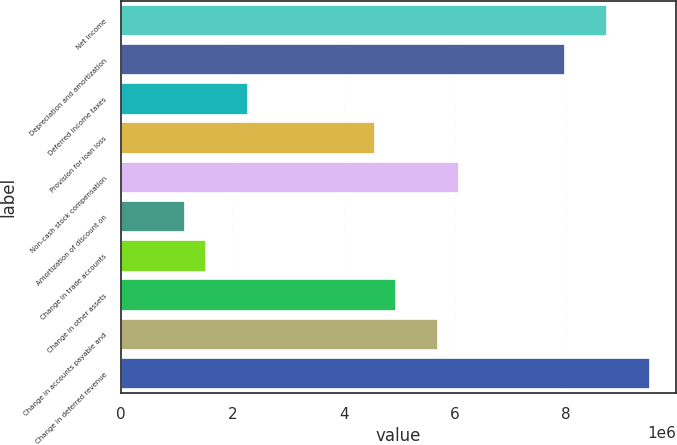Convert chart. <chart><loc_0><loc_0><loc_500><loc_500><bar_chart><fcel>Net income<fcel>Depreciation and amortization<fcel>Deferred income taxes<fcel>Provision for loan loss<fcel>Non-cash stock compensation<fcel>Amortization of discount on<fcel>Change in trade accounts<fcel>Change in other assets<fcel>Change in accounts payable and<fcel>Change in deferred revenue<nl><fcel>8.73656e+06<fcel>7.97705e+06<fcel>2.28078e+06<fcel>4.55929e+06<fcel>6.0783e+06<fcel>1.14152e+06<fcel>1.52128e+06<fcel>4.93904e+06<fcel>5.69854e+06<fcel>9.49606e+06<nl></chart> 